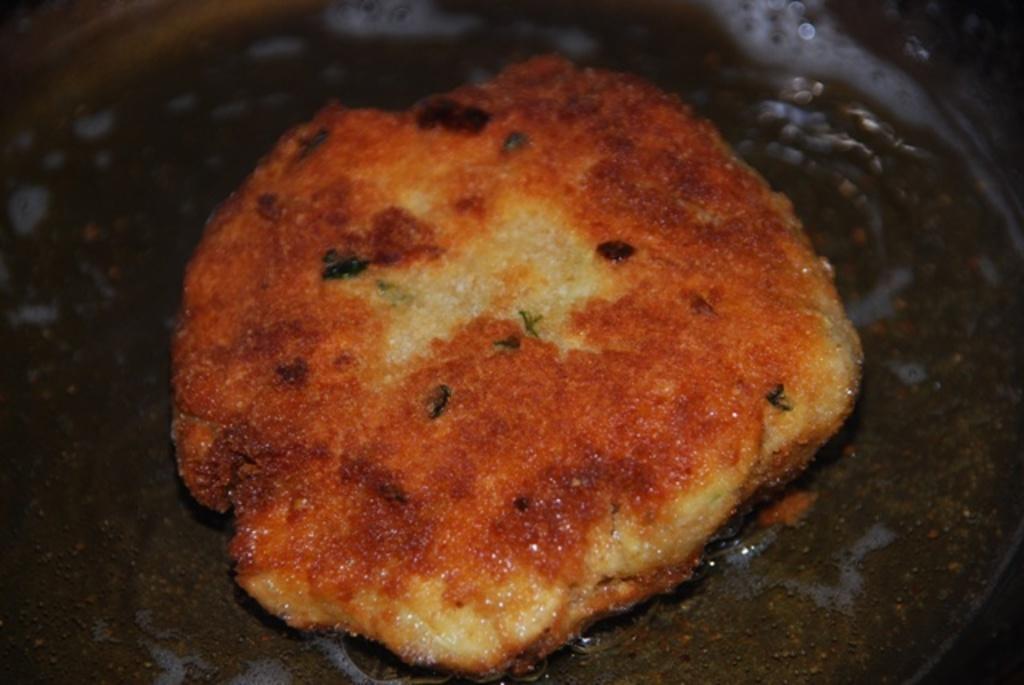In one or two sentences, can you explain what this image depicts? In this image we can see a food item in a pan. 